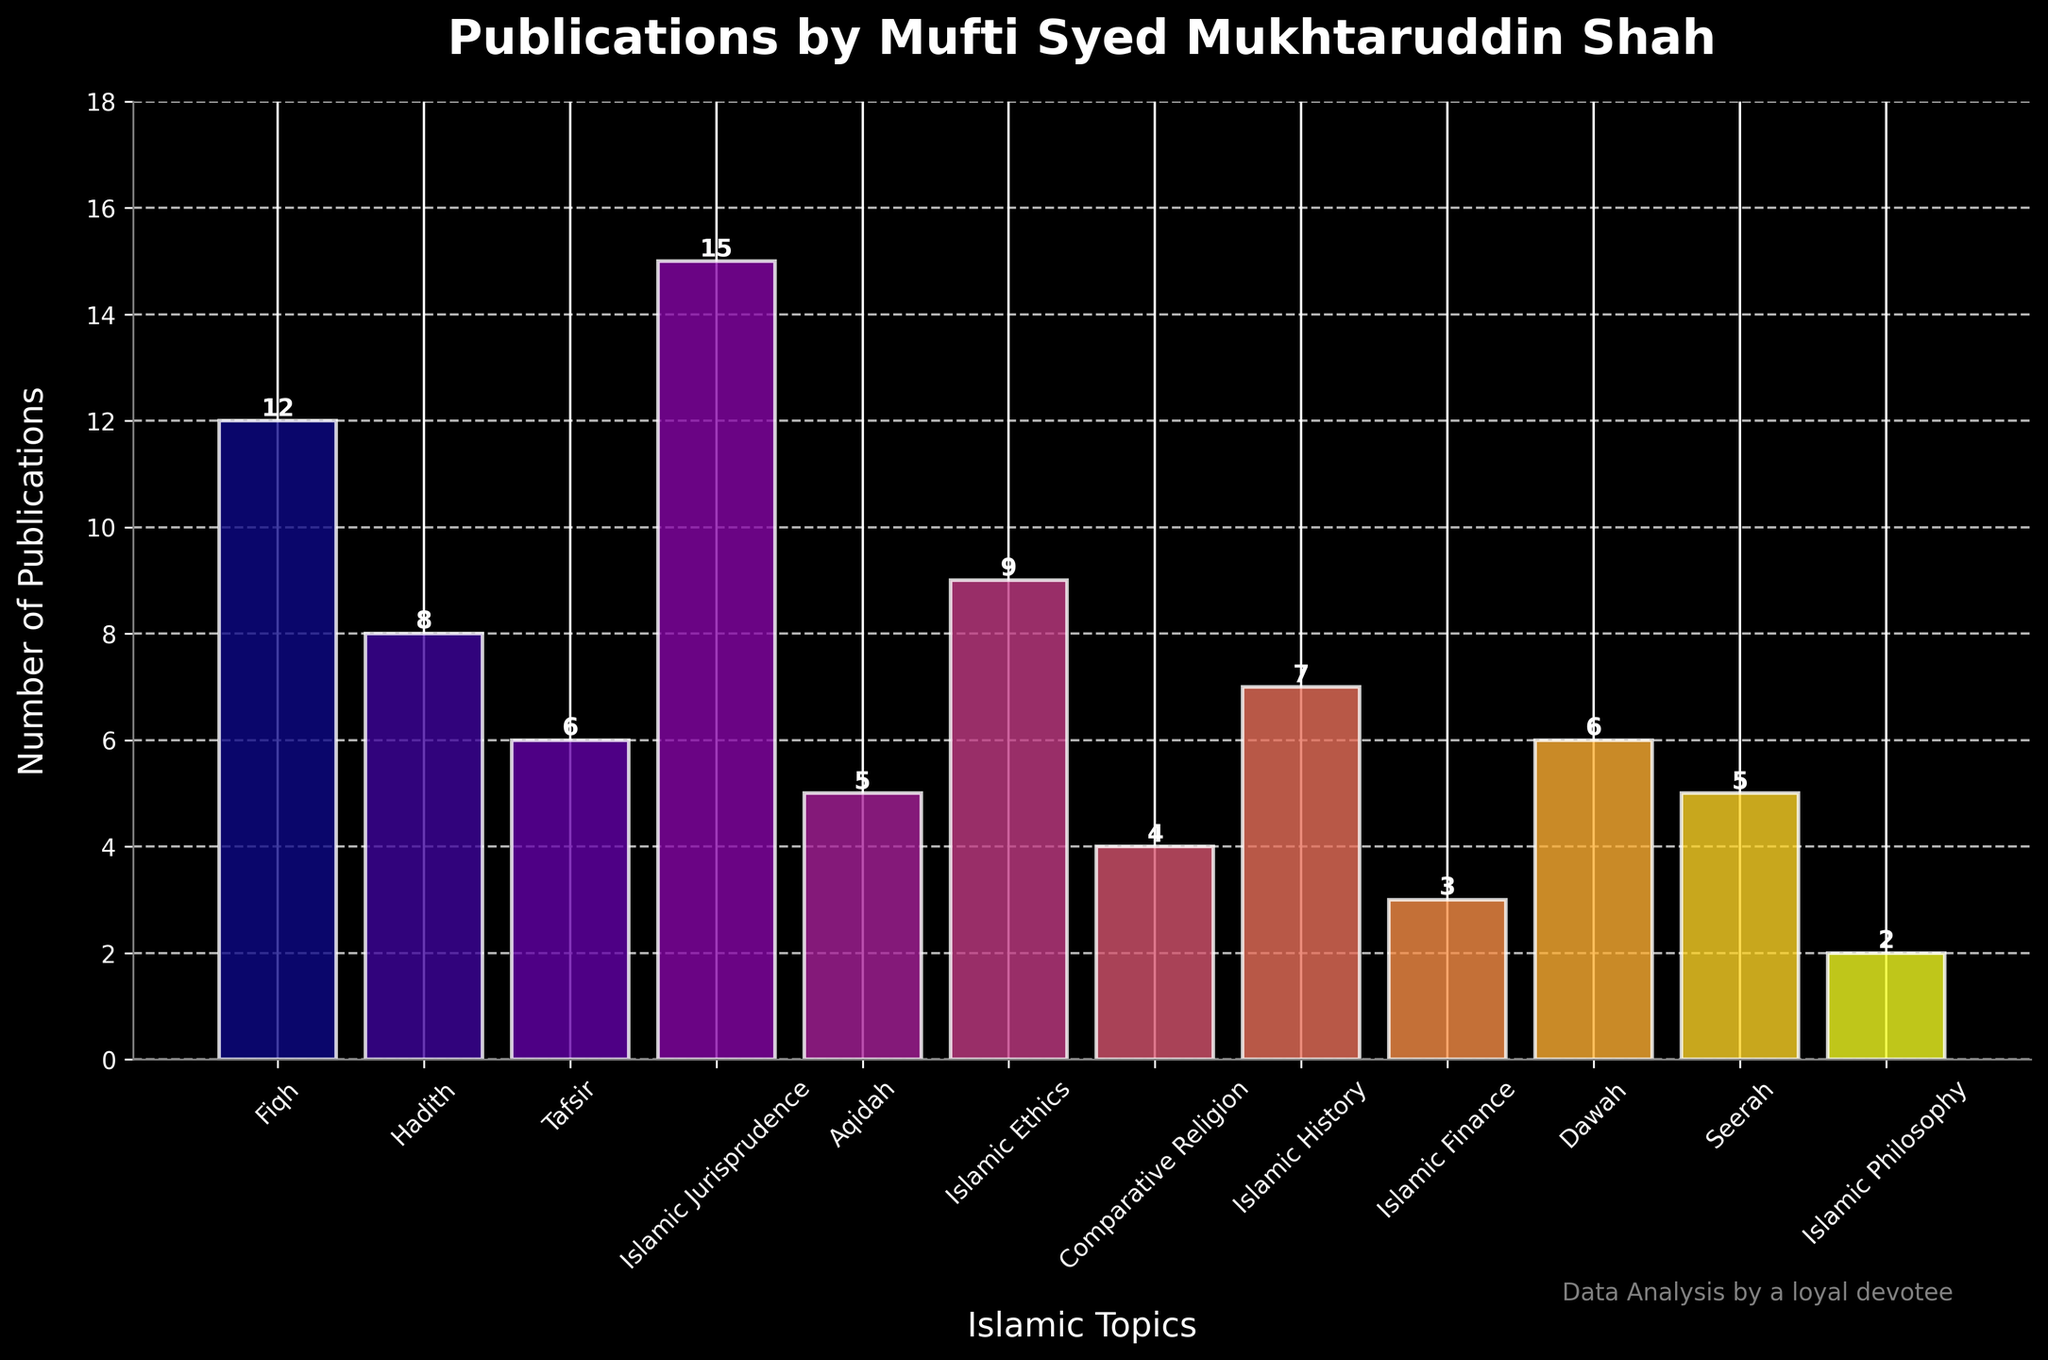Which topic has the highest number of publications? The bar chart indicates that "Islamic Jurisprudence" has the highest bar, representing the topic with the most publications.
Answer: Islamic Jurisprudence How many more publications does "Fiqh" have compared to "Tafsir"? "Fiqh" has 12 publications, and "Tafsir" has 6 publications. Subtracting these values, 12 - 6 = 6 publications.
Answer: 6 What is the total number of publications in "Hadith", "Tafsir", and "Islamic Finance"? The publications for "Hadith" is 8, for "Tafsir" is 6, and for "Islamic Finance" is 3. Summing these values, 8 + 6 + 3 = 17 publications.
Answer: 17 Which two topics have the same number of publications and what is that number? The bar chart shows that "Aqidah" and "Seerah" both have 5 publications each, as indicated by the height of their respective bars.
Answer: Aqidah and Seerah, 5 How many publications are there in total across all topics? Summing all the publications from each topic: 12 + 8 + 6 + 15 + 5 + 9 + 4 + 7 + 3 + 6 + 5 + 2 = 82 publications.
Answer: 82 Identify the topic with the second-highest number of publications. "Fiqh" with 12 publications has the second-highest number after "Islamic Jurisprudence" with 15 publications.
Answer: Fiqh What is the average number of publications across all topics? The total number of publications is 82, and there are 12 topics. Dividing the total by the number of topics, 82 / 12 ≈ 6.83.
Answer: 6.83 How many topics have fewer than 5 publications? The topics with fewer than 5 publications are "Comparative Religion" (4), "Islamic Finance" (3), and "Islamic Philosophy" (2), totaling 3 topics.
Answer: 3 What is the difference in the number of publications between the topics with the most and the least publications? "Islamic Jurisprudence" has the most publications (15) and "Islamic Philosophy" has the least (2). The difference is 15 - 2 = 13 publications.
Answer: 13 Which topic has more publications: "Islamic History" or "Islamic Ethics"? The bar chart shows that "Islamic Ethics" has 9 publications, while "Islamic History" has 7 publications. Therefore, "Islamic Ethics" has more publications.
Answer: Islamic Ethics 